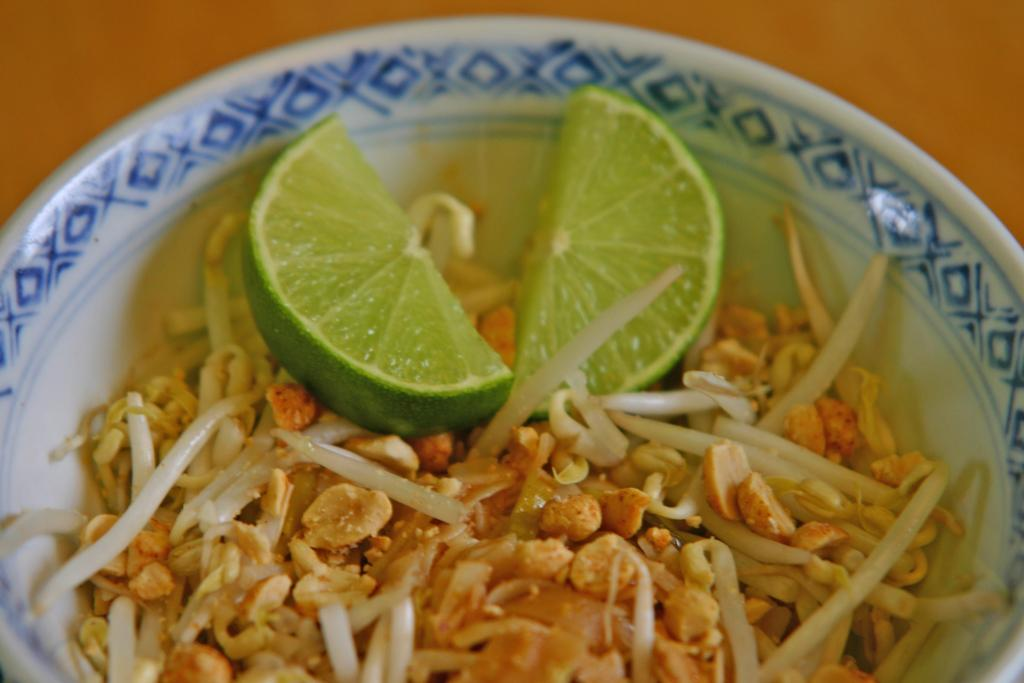What is in the bowl that is visible in the image? The bowl contains food, specifically slices of lemon. Can you describe the contents of the bowl in more detail? Yes, there are slices of lemon in the bowl. What can be seen in the background of the image? The background of the image is blurred. What type of noise can be heard coming from the bedroom in the image? There is no bedroom present in the image, so it's not possible to determine what, if any, noise might be heard. 